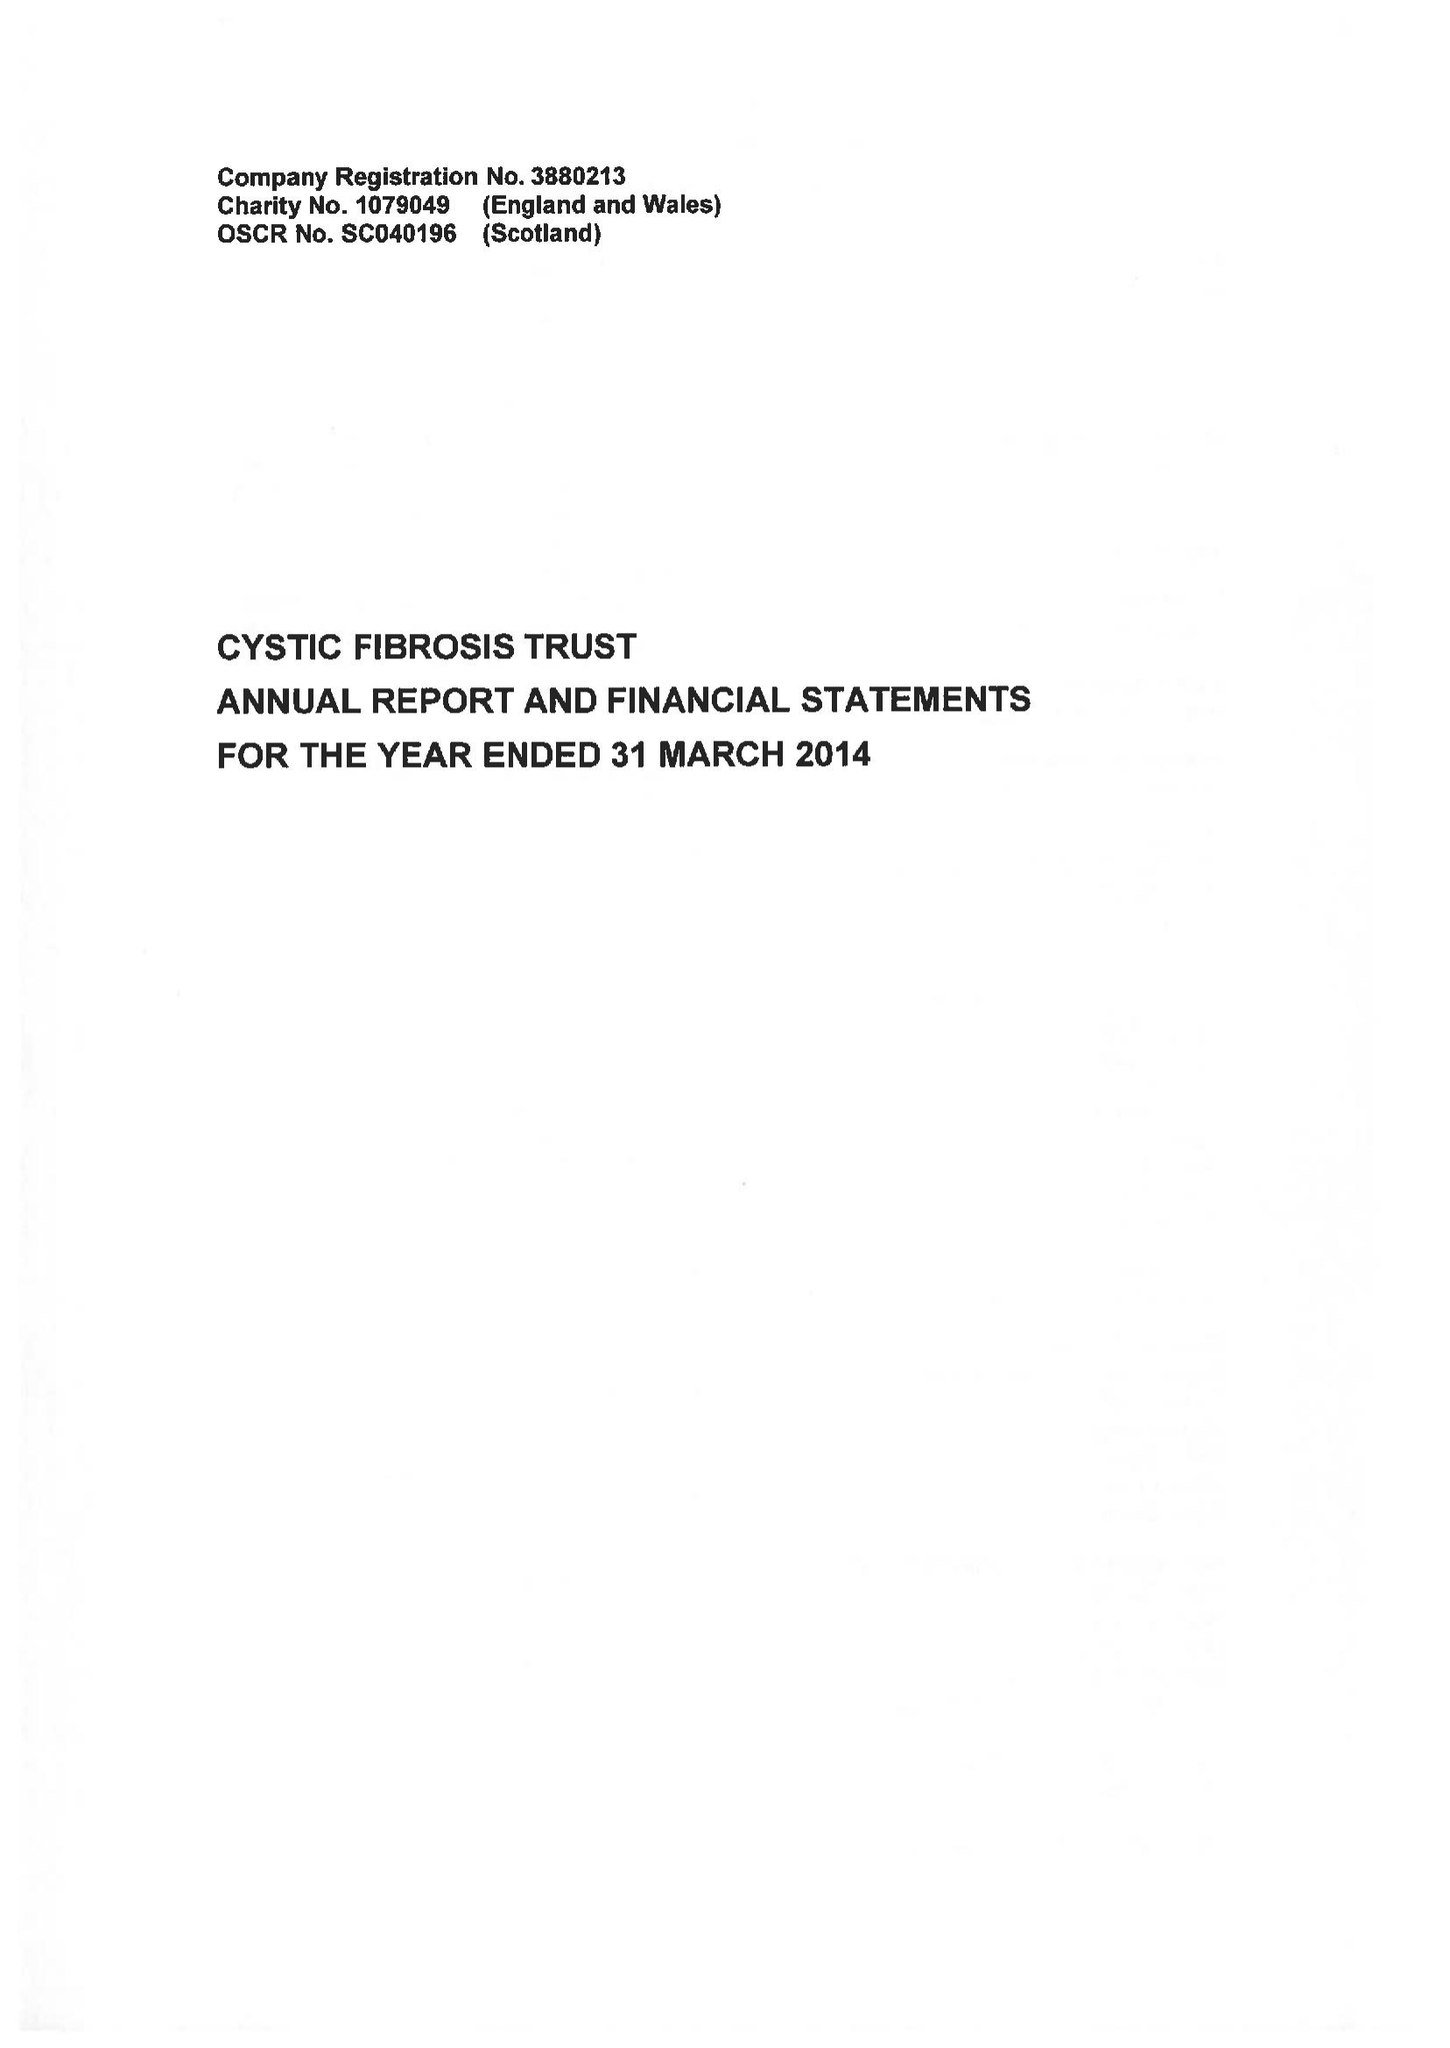What is the value for the address__post_town?
Answer the question using a single word or phrase. LONDON 